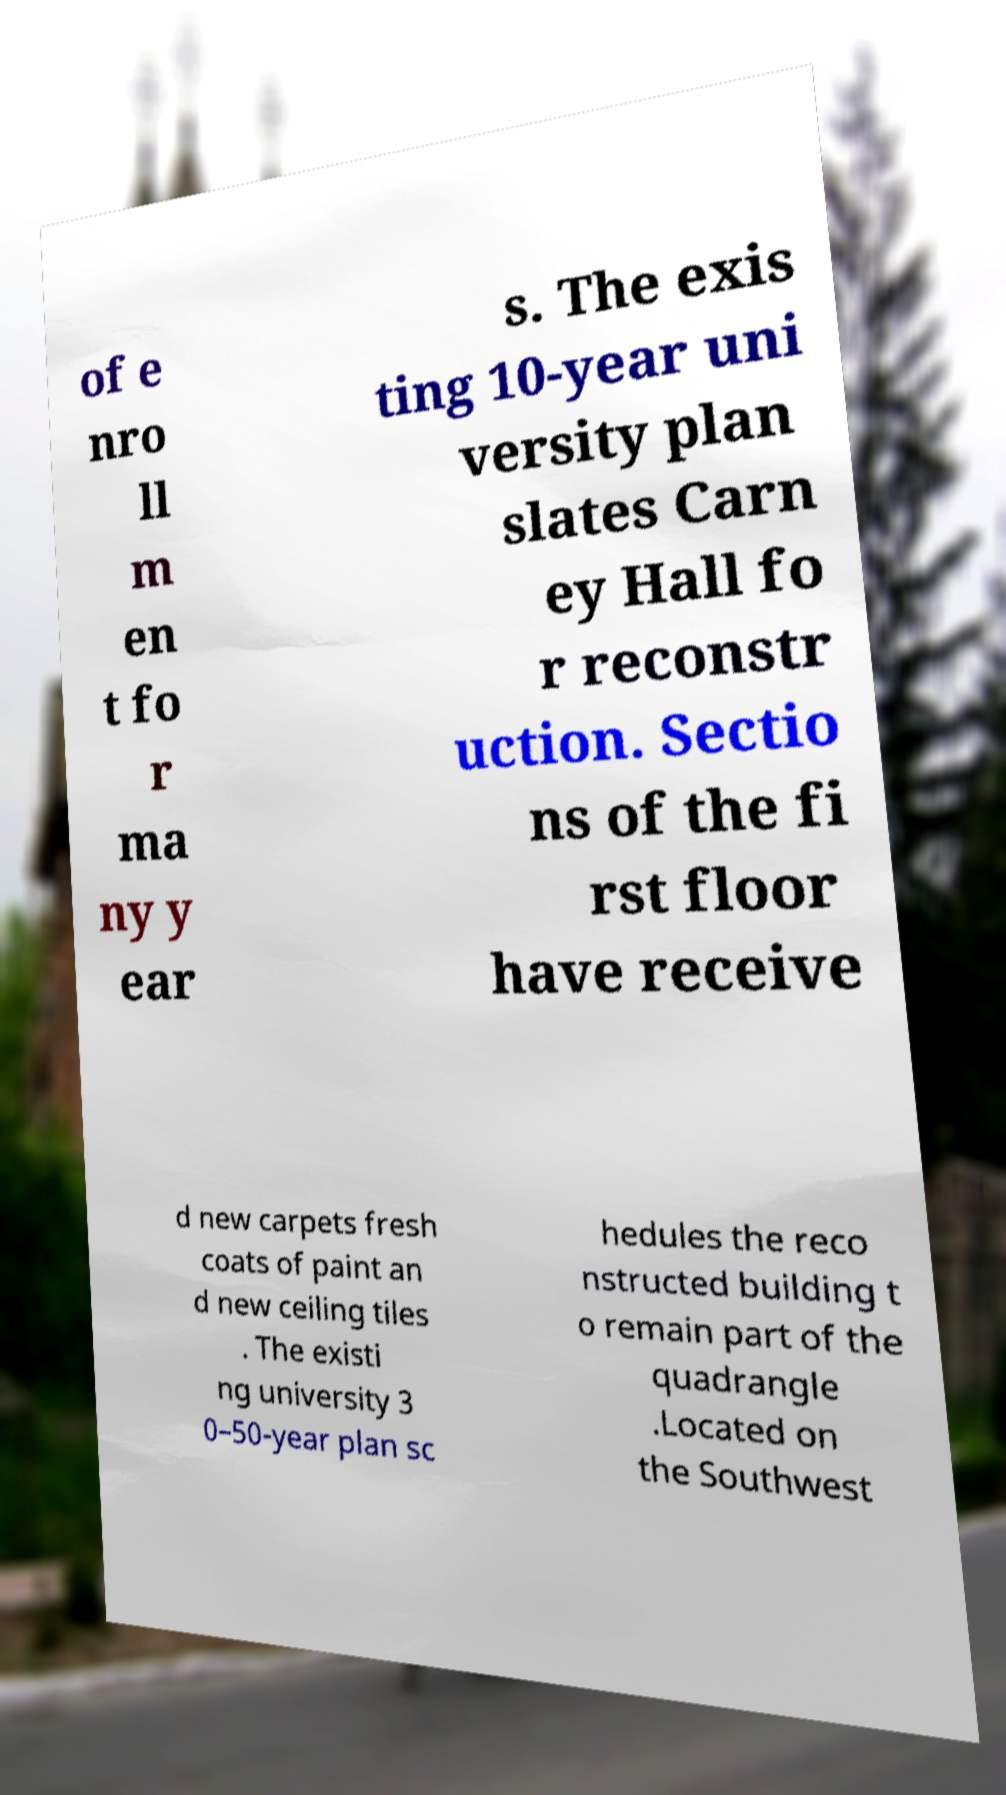Can you read and provide the text displayed in the image?This photo seems to have some interesting text. Can you extract and type it out for me? of e nro ll m en t fo r ma ny y ear s. The exis ting 10-year uni versity plan slates Carn ey Hall fo r reconstr uction. Sectio ns of the fi rst floor have receive d new carpets fresh coats of paint an d new ceiling tiles . The existi ng university 3 0–50-year plan sc hedules the reco nstructed building t o remain part of the quadrangle .Located on the Southwest 